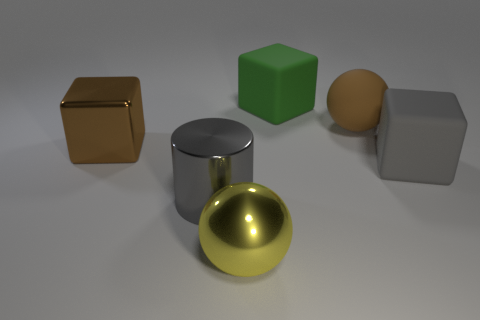Subtract all green rubber cubes. How many cubes are left? 2 Add 1 tiny cyan rubber cylinders. How many objects exist? 7 Subtract all brown cubes. How many cubes are left? 2 Subtract all cylinders. How many objects are left? 5 Subtract 1 balls. How many balls are left? 1 Subtract 0 red balls. How many objects are left? 6 Subtract all red cubes. Subtract all red cylinders. How many cubes are left? 3 Subtract all large green rubber things. Subtract all balls. How many objects are left? 3 Add 1 big brown cubes. How many big brown cubes are left? 2 Add 3 cyan cylinders. How many cyan cylinders exist? 3 